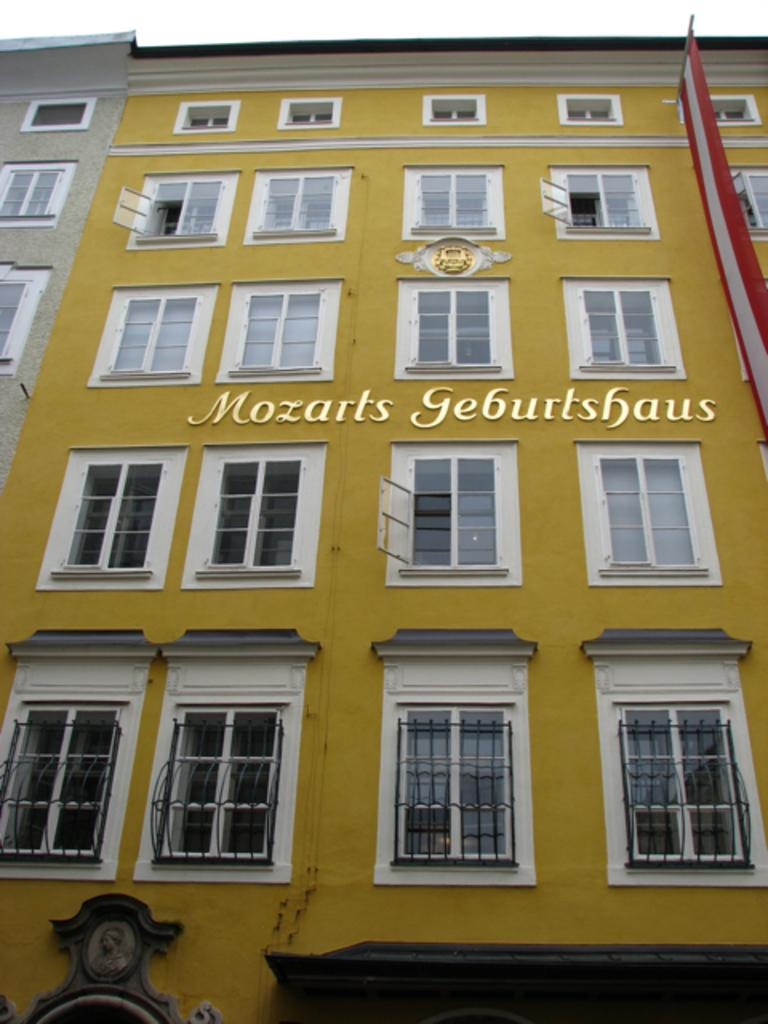What is the main subject of the image? The main subject of the image is a building. Can you describe the building in the image? The building has windows. What is located on the right side of the image? There is a flag on the right side of the image. What can be seen at the bottom of the image? There are objects at the bottom of the image. What type of music can be heard coming from the building in the image? There is no indication of music or any sounds in the image, so it's not possible to determine what, if any, music might be heard. 